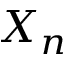Convert formula to latex. <formula><loc_0><loc_0><loc_500><loc_500>X _ { n }</formula> 